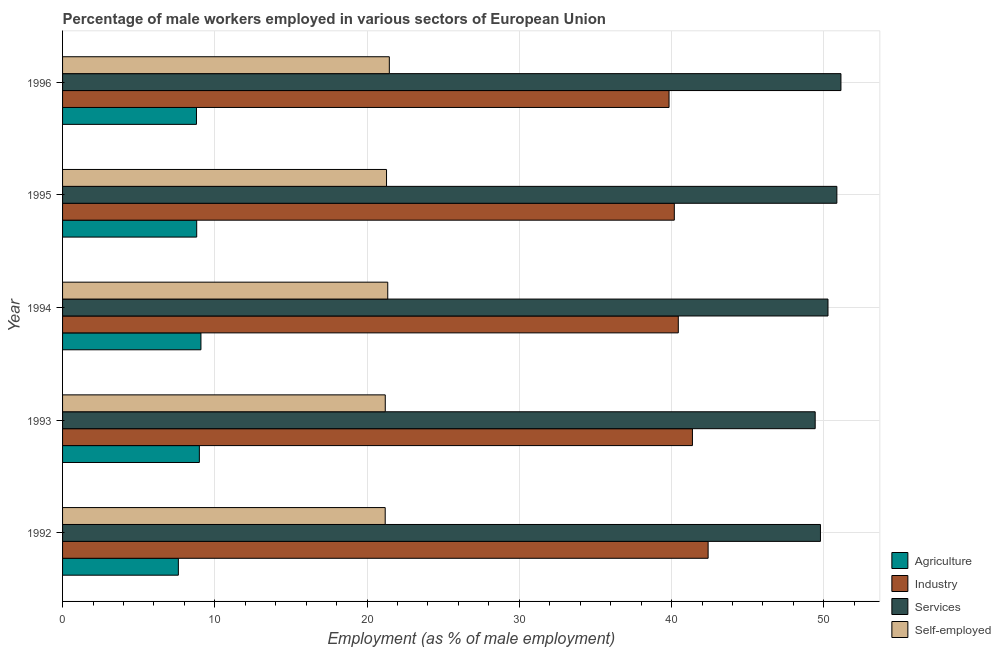How many different coloured bars are there?
Keep it short and to the point. 4. Are the number of bars on each tick of the Y-axis equal?
Your answer should be very brief. Yes. In how many cases, is the number of bars for a given year not equal to the number of legend labels?
Your answer should be compact. 0. What is the percentage of male workers in agriculture in 1996?
Keep it short and to the point. 8.79. Across all years, what is the maximum percentage of self employed male workers?
Your answer should be compact. 21.46. Across all years, what is the minimum percentage of male workers in industry?
Ensure brevity in your answer.  39.83. In which year was the percentage of self employed male workers maximum?
Ensure brevity in your answer.  1996. In which year was the percentage of male workers in agriculture minimum?
Provide a short and direct response. 1992. What is the total percentage of self employed male workers in the graph?
Ensure brevity in your answer.  106.48. What is the difference between the percentage of male workers in industry in 1995 and that in 1996?
Provide a short and direct response. 0.35. What is the difference between the percentage of self employed male workers in 1995 and the percentage of male workers in industry in 1993?
Ensure brevity in your answer.  -20.09. What is the average percentage of male workers in services per year?
Provide a succinct answer. 50.29. In the year 1992, what is the difference between the percentage of male workers in agriculture and percentage of male workers in industry?
Your answer should be very brief. -34.79. What is the ratio of the percentage of male workers in services in 1993 to that in 1995?
Make the answer very short. 0.97. Is the percentage of male workers in services in 1992 less than that in 1996?
Ensure brevity in your answer.  Yes. What is the difference between the highest and the second highest percentage of male workers in agriculture?
Ensure brevity in your answer.  0.1. What is the difference between the highest and the lowest percentage of self employed male workers?
Offer a terse response. 0.27. In how many years, is the percentage of male workers in industry greater than the average percentage of male workers in industry taken over all years?
Make the answer very short. 2. Is it the case that in every year, the sum of the percentage of self employed male workers and percentage of male workers in agriculture is greater than the sum of percentage of male workers in services and percentage of male workers in industry?
Offer a terse response. No. What does the 1st bar from the top in 1993 represents?
Your answer should be very brief. Self-employed. What does the 4th bar from the bottom in 1993 represents?
Offer a terse response. Self-employed. What is the difference between two consecutive major ticks on the X-axis?
Provide a short and direct response. 10. Does the graph contain grids?
Offer a very short reply. Yes. Where does the legend appear in the graph?
Ensure brevity in your answer.  Bottom right. How are the legend labels stacked?
Your answer should be compact. Vertical. What is the title of the graph?
Provide a succinct answer. Percentage of male workers employed in various sectors of European Union. What is the label or title of the X-axis?
Ensure brevity in your answer.  Employment (as % of male employment). What is the label or title of the Y-axis?
Make the answer very short. Year. What is the Employment (as % of male employment) in Agriculture in 1992?
Provide a succinct answer. 7.6. What is the Employment (as % of male employment) in Industry in 1992?
Ensure brevity in your answer.  42.4. What is the Employment (as % of male employment) in Services in 1992?
Keep it short and to the point. 49.78. What is the Employment (as % of male employment) in Self-employed in 1992?
Keep it short and to the point. 21.19. What is the Employment (as % of male employment) in Agriculture in 1993?
Your response must be concise. 8.98. What is the Employment (as % of male employment) in Industry in 1993?
Your answer should be very brief. 41.37. What is the Employment (as % of male employment) in Services in 1993?
Offer a very short reply. 49.43. What is the Employment (as % of male employment) of Self-employed in 1993?
Your answer should be compact. 21.19. What is the Employment (as % of male employment) of Agriculture in 1994?
Your response must be concise. 9.09. What is the Employment (as % of male employment) in Industry in 1994?
Keep it short and to the point. 40.44. What is the Employment (as % of male employment) of Services in 1994?
Your answer should be compact. 50.27. What is the Employment (as % of male employment) in Self-employed in 1994?
Provide a succinct answer. 21.36. What is the Employment (as % of male employment) in Agriculture in 1995?
Ensure brevity in your answer.  8.81. What is the Employment (as % of male employment) in Industry in 1995?
Provide a short and direct response. 40.18. What is the Employment (as % of male employment) of Services in 1995?
Provide a succinct answer. 50.85. What is the Employment (as % of male employment) of Self-employed in 1995?
Make the answer very short. 21.28. What is the Employment (as % of male employment) of Agriculture in 1996?
Your answer should be compact. 8.79. What is the Employment (as % of male employment) in Industry in 1996?
Your response must be concise. 39.83. What is the Employment (as % of male employment) of Services in 1996?
Make the answer very short. 51.12. What is the Employment (as % of male employment) of Self-employed in 1996?
Offer a very short reply. 21.46. Across all years, what is the maximum Employment (as % of male employment) of Agriculture?
Make the answer very short. 9.09. Across all years, what is the maximum Employment (as % of male employment) of Industry?
Offer a terse response. 42.4. Across all years, what is the maximum Employment (as % of male employment) in Services?
Keep it short and to the point. 51.12. Across all years, what is the maximum Employment (as % of male employment) in Self-employed?
Your response must be concise. 21.46. Across all years, what is the minimum Employment (as % of male employment) in Agriculture?
Ensure brevity in your answer.  7.6. Across all years, what is the minimum Employment (as % of male employment) in Industry?
Keep it short and to the point. 39.83. Across all years, what is the minimum Employment (as % of male employment) in Services?
Offer a very short reply. 49.43. Across all years, what is the minimum Employment (as % of male employment) in Self-employed?
Your response must be concise. 21.19. What is the total Employment (as % of male employment) of Agriculture in the graph?
Your response must be concise. 43.28. What is the total Employment (as % of male employment) in Industry in the graph?
Offer a terse response. 204.22. What is the total Employment (as % of male employment) of Services in the graph?
Your answer should be very brief. 251.46. What is the total Employment (as % of male employment) in Self-employed in the graph?
Offer a terse response. 106.48. What is the difference between the Employment (as % of male employment) of Agriculture in 1992 and that in 1993?
Offer a very short reply. -1.38. What is the difference between the Employment (as % of male employment) of Industry in 1992 and that in 1993?
Offer a terse response. 1.03. What is the difference between the Employment (as % of male employment) of Services in 1992 and that in 1993?
Provide a short and direct response. 0.35. What is the difference between the Employment (as % of male employment) of Self-employed in 1992 and that in 1993?
Offer a terse response. -0. What is the difference between the Employment (as % of male employment) in Agriculture in 1992 and that in 1994?
Give a very brief answer. -1.48. What is the difference between the Employment (as % of male employment) in Industry in 1992 and that in 1994?
Provide a short and direct response. 1.96. What is the difference between the Employment (as % of male employment) in Services in 1992 and that in 1994?
Give a very brief answer. -0.49. What is the difference between the Employment (as % of male employment) in Self-employed in 1992 and that in 1994?
Your response must be concise. -0.17. What is the difference between the Employment (as % of male employment) of Agriculture in 1992 and that in 1995?
Ensure brevity in your answer.  -1.2. What is the difference between the Employment (as % of male employment) of Industry in 1992 and that in 1995?
Your response must be concise. 2.22. What is the difference between the Employment (as % of male employment) of Services in 1992 and that in 1995?
Offer a very short reply. -1.08. What is the difference between the Employment (as % of male employment) of Self-employed in 1992 and that in 1995?
Your response must be concise. -0.09. What is the difference between the Employment (as % of male employment) of Agriculture in 1992 and that in 1996?
Ensure brevity in your answer.  -1.19. What is the difference between the Employment (as % of male employment) in Industry in 1992 and that in 1996?
Provide a short and direct response. 2.57. What is the difference between the Employment (as % of male employment) in Services in 1992 and that in 1996?
Your response must be concise. -1.35. What is the difference between the Employment (as % of male employment) of Self-employed in 1992 and that in 1996?
Give a very brief answer. -0.27. What is the difference between the Employment (as % of male employment) in Agriculture in 1993 and that in 1994?
Provide a succinct answer. -0.1. What is the difference between the Employment (as % of male employment) in Industry in 1993 and that in 1994?
Make the answer very short. 0.93. What is the difference between the Employment (as % of male employment) in Services in 1993 and that in 1994?
Provide a succinct answer. -0.84. What is the difference between the Employment (as % of male employment) of Self-employed in 1993 and that in 1994?
Give a very brief answer. -0.16. What is the difference between the Employment (as % of male employment) of Agriculture in 1993 and that in 1995?
Provide a short and direct response. 0.17. What is the difference between the Employment (as % of male employment) of Industry in 1993 and that in 1995?
Ensure brevity in your answer.  1.19. What is the difference between the Employment (as % of male employment) of Services in 1993 and that in 1995?
Provide a succinct answer. -1.42. What is the difference between the Employment (as % of male employment) in Self-employed in 1993 and that in 1995?
Give a very brief answer. -0.08. What is the difference between the Employment (as % of male employment) in Agriculture in 1993 and that in 1996?
Your answer should be compact. 0.19. What is the difference between the Employment (as % of male employment) in Industry in 1993 and that in 1996?
Make the answer very short. 1.54. What is the difference between the Employment (as % of male employment) of Services in 1993 and that in 1996?
Ensure brevity in your answer.  -1.69. What is the difference between the Employment (as % of male employment) of Self-employed in 1993 and that in 1996?
Give a very brief answer. -0.27. What is the difference between the Employment (as % of male employment) of Agriculture in 1994 and that in 1995?
Offer a very short reply. 0.28. What is the difference between the Employment (as % of male employment) in Industry in 1994 and that in 1995?
Provide a succinct answer. 0.26. What is the difference between the Employment (as % of male employment) in Services in 1994 and that in 1995?
Offer a very short reply. -0.58. What is the difference between the Employment (as % of male employment) of Self-employed in 1994 and that in 1995?
Provide a short and direct response. 0.08. What is the difference between the Employment (as % of male employment) in Agriculture in 1994 and that in 1996?
Your response must be concise. 0.29. What is the difference between the Employment (as % of male employment) in Industry in 1994 and that in 1996?
Your answer should be very brief. 0.61. What is the difference between the Employment (as % of male employment) in Services in 1994 and that in 1996?
Provide a short and direct response. -0.85. What is the difference between the Employment (as % of male employment) of Self-employed in 1994 and that in 1996?
Your answer should be compact. -0.1. What is the difference between the Employment (as % of male employment) of Agriculture in 1995 and that in 1996?
Keep it short and to the point. 0.01. What is the difference between the Employment (as % of male employment) of Industry in 1995 and that in 1996?
Ensure brevity in your answer.  0.35. What is the difference between the Employment (as % of male employment) of Services in 1995 and that in 1996?
Make the answer very short. -0.27. What is the difference between the Employment (as % of male employment) of Self-employed in 1995 and that in 1996?
Provide a succinct answer. -0.18. What is the difference between the Employment (as % of male employment) of Agriculture in 1992 and the Employment (as % of male employment) of Industry in 1993?
Keep it short and to the point. -33.76. What is the difference between the Employment (as % of male employment) in Agriculture in 1992 and the Employment (as % of male employment) in Services in 1993?
Ensure brevity in your answer.  -41.83. What is the difference between the Employment (as % of male employment) in Agriculture in 1992 and the Employment (as % of male employment) in Self-employed in 1993?
Provide a short and direct response. -13.59. What is the difference between the Employment (as % of male employment) of Industry in 1992 and the Employment (as % of male employment) of Services in 1993?
Make the answer very short. -7.03. What is the difference between the Employment (as % of male employment) of Industry in 1992 and the Employment (as % of male employment) of Self-employed in 1993?
Offer a terse response. 21.2. What is the difference between the Employment (as % of male employment) of Services in 1992 and the Employment (as % of male employment) of Self-employed in 1993?
Give a very brief answer. 28.58. What is the difference between the Employment (as % of male employment) in Agriculture in 1992 and the Employment (as % of male employment) in Industry in 1994?
Offer a terse response. -32.84. What is the difference between the Employment (as % of male employment) in Agriculture in 1992 and the Employment (as % of male employment) in Services in 1994?
Give a very brief answer. -42.67. What is the difference between the Employment (as % of male employment) in Agriculture in 1992 and the Employment (as % of male employment) in Self-employed in 1994?
Make the answer very short. -13.75. What is the difference between the Employment (as % of male employment) in Industry in 1992 and the Employment (as % of male employment) in Services in 1994?
Ensure brevity in your answer.  -7.87. What is the difference between the Employment (as % of male employment) in Industry in 1992 and the Employment (as % of male employment) in Self-employed in 1994?
Provide a succinct answer. 21.04. What is the difference between the Employment (as % of male employment) of Services in 1992 and the Employment (as % of male employment) of Self-employed in 1994?
Your answer should be very brief. 28.42. What is the difference between the Employment (as % of male employment) in Agriculture in 1992 and the Employment (as % of male employment) in Industry in 1995?
Offer a very short reply. -32.57. What is the difference between the Employment (as % of male employment) of Agriculture in 1992 and the Employment (as % of male employment) of Services in 1995?
Offer a very short reply. -43.25. What is the difference between the Employment (as % of male employment) in Agriculture in 1992 and the Employment (as % of male employment) in Self-employed in 1995?
Provide a succinct answer. -13.67. What is the difference between the Employment (as % of male employment) of Industry in 1992 and the Employment (as % of male employment) of Services in 1995?
Keep it short and to the point. -8.46. What is the difference between the Employment (as % of male employment) of Industry in 1992 and the Employment (as % of male employment) of Self-employed in 1995?
Offer a very short reply. 21.12. What is the difference between the Employment (as % of male employment) in Services in 1992 and the Employment (as % of male employment) in Self-employed in 1995?
Offer a terse response. 28.5. What is the difference between the Employment (as % of male employment) in Agriculture in 1992 and the Employment (as % of male employment) in Industry in 1996?
Offer a terse response. -32.23. What is the difference between the Employment (as % of male employment) of Agriculture in 1992 and the Employment (as % of male employment) of Services in 1996?
Make the answer very short. -43.52. What is the difference between the Employment (as % of male employment) in Agriculture in 1992 and the Employment (as % of male employment) in Self-employed in 1996?
Provide a short and direct response. -13.86. What is the difference between the Employment (as % of male employment) of Industry in 1992 and the Employment (as % of male employment) of Services in 1996?
Give a very brief answer. -8.72. What is the difference between the Employment (as % of male employment) of Industry in 1992 and the Employment (as % of male employment) of Self-employed in 1996?
Keep it short and to the point. 20.94. What is the difference between the Employment (as % of male employment) in Services in 1992 and the Employment (as % of male employment) in Self-employed in 1996?
Offer a very short reply. 28.32. What is the difference between the Employment (as % of male employment) of Agriculture in 1993 and the Employment (as % of male employment) of Industry in 1994?
Make the answer very short. -31.46. What is the difference between the Employment (as % of male employment) in Agriculture in 1993 and the Employment (as % of male employment) in Services in 1994?
Your answer should be compact. -41.29. What is the difference between the Employment (as % of male employment) of Agriculture in 1993 and the Employment (as % of male employment) of Self-employed in 1994?
Your answer should be very brief. -12.37. What is the difference between the Employment (as % of male employment) of Industry in 1993 and the Employment (as % of male employment) of Services in 1994?
Offer a terse response. -8.9. What is the difference between the Employment (as % of male employment) of Industry in 1993 and the Employment (as % of male employment) of Self-employed in 1994?
Make the answer very short. 20.01. What is the difference between the Employment (as % of male employment) in Services in 1993 and the Employment (as % of male employment) in Self-employed in 1994?
Your answer should be very brief. 28.07. What is the difference between the Employment (as % of male employment) in Agriculture in 1993 and the Employment (as % of male employment) in Industry in 1995?
Your answer should be compact. -31.2. What is the difference between the Employment (as % of male employment) of Agriculture in 1993 and the Employment (as % of male employment) of Services in 1995?
Provide a short and direct response. -41.87. What is the difference between the Employment (as % of male employment) in Agriculture in 1993 and the Employment (as % of male employment) in Self-employed in 1995?
Give a very brief answer. -12.29. What is the difference between the Employment (as % of male employment) in Industry in 1993 and the Employment (as % of male employment) in Services in 1995?
Keep it short and to the point. -9.49. What is the difference between the Employment (as % of male employment) in Industry in 1993 and the Employment (as % of male employment) in Self-employed in 1995?
Offer a very short reply. 20.09. What is the difference between the Employment (as % of male employment) of Services in 1993 and the Employment (as % of male employment) of Self-employed in 1995?
Give a very brief answer. 28.15. What is the difference between the Employment (as % of male employment) in Agriculture in 1993 and the Employment (as % of male employment) in Industry in 1996?
Offer a terse response. -30.85. What is the difference between the Employment (as % of male employment) in Agriculture in 1993 and the Employment (as % of male employment) in Services in 1996?
Your answer should be compact. -42.14. What is the difference between the Employment (as % of male employment) of Agriculture in 1993 and the Employment (as % of male employment) of Self-employed in 1996?
Offer a very short reply. -12.48. What is the difference between the Employment (as % of male employment) in Industry in 1993 and the Employment (as % of male employment) in Services in 1996?
Your response must be concise. -9.75. What is the difference between the Employment (as % of male employment) in Industry in 1993 and the Employment (as % of male employment) in Self-employed in 1996?
Your answer should be compact. 19.91. What is the difference between the Employment (as % of male employment) of Services in 1993 and the Employment (as % of male employment) of Self-employed in 1996?
Your answer should be compact. 27.97. What is the difference between the Employment (as % of male employment) in Agriculture in 1994 and the Employment (as % of male employment) in Industry in 1995?
Keep it short and to the point. -31.09. What is the difference between the Employment (as % of male employment) in Agriculture in 1994 and the Employment (as % of male employment) in Services in 1995?
Your answer should be compact. -41.77. What is the difference between the Employment (as % of male employment) in Agriculture in 1994 and the Employment (as % of male employment) in Self-employed in 1995?
Ensure brevity in your answer.  -12.19. What is the difference between the Employment (as % of male employment) of Industry in 1994 and the Employment (as % of male employment) of Services in 1995?
Ensure brevity in your answer.  -10.41. What is the difference between the Employment (as % of male employment) in Industry in 1994 and the Employment (as % of male employment) in Self-employed in 1995?
Provide a succinct answer. 19.16. What is the difference between the Employment (as % of male employment) of Services in 1994 and the Employment (as % of male employment) of Self-employed in 1995?
Provide a short and direct response. 28.99. What is the difference between the Employment (as % of male employment) in Agriculture in 1994 and the Employment (as % of male employment) in Industry in 1996?
Offer a terse response. -30.75. What is the difference between the Employment (as % of male employment) in Agriculture in 1994 and the Employment (as % of male employment) in Services in 1996?
Your response must be concise. -42.03. What is the difference between the Employment (as % of male employment) of Agriculture in 1994 and the Employment (as % of male employment) of Self-employed in 1996?
Provide a short and direct response. -12.37. What is the difference between the Employment (as % of male employment) in Industry in 1994 and the Employment (as % of male employment) in Services in 1996?
Provide a short and direct response. -10.68. What is the difference between the Employment (as % of male employment) of Industry in 1994 and the Employment (as % of male employment) of Self-employed in 1996?
Your response must be concise. 18.98. What is the difference between the Employment (as % of male employment) of Services in 1994 and the Employment (as % of male employment) of Self-employed in 1996?
Provide a short and direct response. 28.81. What is the difference between the Employment (as % of male employment) in Agriculture in 1995 and the Employment (as % of male employment) in Industry in 1996?
Your response must be concise. -31.02. What is the difference between the Employment (as % of male employment) of Agriculture in 1995 and the Employment (as % of male employment) of Services in 1996?
Provide a short and direct response. -42.31. What is the difference between the Employment (as % of male employment) of Agriculture in 1995 and the Employment (as % of male employment) of Self-employed in 1996?
Give a very brief answer. -12.65. What is the difference between the Employment (as % of male employment) in Industry in 1995 and the Employment (as % of male employment) in Services in 1996?
Your answer should be compact. -10.94. What is the difference between the Employment (as % of male employment) of Industry in 1995 and the Employment (as % of male employment) of Self-employed in 1996?
Make the answer very short. 18.72. What is the difference between the Employment (as % of male employment) in Services in 1995 and the Employment (as % of male employment) in Self-employed in 1996?
Ensure brevity in your answer.  29.39. What is the average Employment (as % of male employment) in Agriculture per year?
Give a very brief answer. 8.66. What is the average Employment (as % of male employment) in Industry per year?
Your response must be concise. 40.84. What is the average Employment (as % of male employment) in Services per year?
Your answer should be very brief. 50.29. What is the average Employment (as % of male employment) in Self-employed per year?
Give a very brief answer. 21.3. In the year 1992, what is the difference between the Employment (as % of male employment) in Agriculture and Employment (as % of male employment) in Industry?
Offer a very short reply. -34.79. In the year 1992, what is the difference between the Employment (as % of male employment) of Agriculture and Employment (as % of male employment) of Services?
Give a very brief answer. -42.17. In the year 1992, what is the difference between the Employment (as % of male employment) of Agriculture and Employment (as % of male employment) of Self-employed?
Offer a terse response. -13.59. In the year 1992, what is the difference between the Employment (as % of male employment) of Industry and Employment (as % of male employment) of Services?
Provide a short and direct response. -7.38. In the year 1992, what is the difference between the Employment (as % of male employment) of Industry and Employment (as % of male employment) of Self-employed?
Provide a short and direct response. 21.21. In the year 1992, what is the difference between the Employment (as % of male employment) of Services and Employment (as % of male employment) of Self-employed?
Give a very brief answer. 28.59. In the year 1993, what is the difference between the Employment (as % of male employment) in Agriculture and Employment (as % of male employment) in Industry?
Provide a short and direct response. -32.39. In the year 1993, what is the difference between the Employment (as % of male employment) in Agriculture and Employment (as % of male employment) in Services?
Provide a short and direct response. -40.45. In the year 1993, what is the difference between the Employment (as % of male employment) of Agriculture and Employment (as % of male employment) of Self-employed?
Your answer should be very brief. -12.21. In the year 1993, what is the difference between the Employment (as % of male employment) in Industry and Employment (as % of male employment) in Services?
Offer a very short reply. -8.06. In the year 1993, what is the difference between the Employment (as % of male employment) of Industry and Employment (as % of male employment) of Self-employed?
Ensure brevity in your answer.  20.17. In the year 1993, what is the difference between the Employment (as % of male employment) of Services and Employment (as % of male employment) of Self-employed?
Provide a succinct answer. 28.24. In the year 1994, what is the difference between the Employment (as % of male employment) of Agriculture and Employment (as % of male employment) of Industry?
Keep it short and to the point. -31.35. In the year 1994, what is the difference between the Employment (as % of male employment) of Agriculture and Employment (as % of male employment) of Services?
Provide a succinct answer. -41.18. In the year 1994, what is the difference between the Employment (as % of male employment) in Agriculture and Employment (as % of male employment) in Self-employed?
Keep it short and to the point. -12.27. In the year 1994, what is the difference between the Employment (as % of male employment) in Industry and Employment (as % of male employment) in Services?
Your response must be concise. -9.83. In the year 1994, what is the difference between the Employment (as % of male employment) in Industry and Employment (as % of male employment) in Self-employed?
Your response must be concise. 19.08. In the year 1994, what is the difference between the Employment (as % of male employment) of Services and Employment (as % of male employment) of Self-employed?
Your response must be concise. 28.91. In the year 1995, what is the difference between the Employment (as % of male employment) of Agriculture and Employment (as % of male employment) of Industry?
Your answer should be very brief. -31.37. In the year 1995, what is the difference between the Employment (as % of male employment) of Agriculture and Employment (as % of male employment) of Services?
Make the answer very short. -42.04. In the year 1995, what is the difference between the Employment (as % of male employment) in Agriculture and Employment (as % of male employment) in Self-employed?
Offer a terse response. -12.47. In the year 1995, what is the difference between the Employment (as % of male employment) in Industry and Employment (as % of male employment) in Services?
Give a very brief answer. -10.68. In the year 1995, what is the difference between the Employment (as % of male employment) in Industry and Employment (as % of male employment) in Self-employed?
Your answer should be compact. 18.9. In the year 1995, what is the difference between the Employment (as % of male employment) in Services and Employment (as % of male employment) in Self-employed?
Provide a succinct answer. 29.58. In the year 1996, what is the difference between the Employment (as % of male employment) of Agriculture and Employment (as % of male employment) of Industry?
Offer a very short reply. -31.04. In the year 1996, what is the difference between the Employment (as % of male employment) of Agriculture and Employment (as % of male employment) of Services?
Offer a very short reply. -42.33. In the year 1996, what is the difference between the Employment (as % of male employment) in Agriculture and Employment (as % of male employment) in Self-employed?
Offer a terse response. -12.67. In the year 1996, what is the difference between the Employment (as % of male employment) in Industry and Employment (as % of male employment) in Services?
Offer a very short reply. -11.29. In the year 1996, what is the difference between the Employment (as % of male employment) of Industry and Employment (as % of male employment) of Self-employed?
Provide a succinct answer. 18.37. In the year 1996, what is the difference between the Employment (as % of male employment) of Services and Employment (as % of male employment) of Self-employed?
Ensure brevity in your answer.  29.66. What is the ratio of the Employment (as % of male employment) of Agriculture in 1992 to that in 1993?
Provide a short and direct response. 0.85. What is the ratio of the Employment (as % of male employment) of Industry in 1992 to that in 1993?
Ensure brevity in your answer.  1.02. What is the ratio of the Employment (as % of male employment) in Agriculture in 1992 to that in 1994?
Offer a terse response. 0.84. What is the ratio of the Employment (as % of male employment) in Industry in 1992 to that in 1994?
Make the answer very short. 1.05. What is the ratio of the Employment (as % of male employment) of Services in 1992 to that in 1994?
Your response must be concise. 0.99. What is the ratio of the Employment (as % of male employment) of Agriculture in 1992 to that in 1995?
Give a very brief answer. 0.86. What is the ratio of the Employment (as % of male employment) of Industry in 1992 to that in 1995?
Keep it short and to the point. 1.06. What is the ratio of the Employment (as % of male employment) in Services in 1992 to that in 1995?
Provide a short and direct response. 0.98. What is the ratio of the Employment (as % of male employment) in Agriculture in 1992 to that in 1996?
Offer a terse response. 0.86. What is the ratio of the Employment (as % of male employment) of Industry in 1992 to that in 1996?
Your response must be concise. 1.06. What is the ratio of the Employment (as % of male employment) in Services in 1992 to that in 1996?
Your answer should be compact. 0.97. What is the ratio of the Employment (as % of male employment) of Self-employed in 1992 to that in 1996?
Your response must be concise. 0.99. What is the ratio of the Employment (as % of male employment) of Industry in 1993 to that in 1994?
Your answer should be compact. 1.02. What is the ratio of the Employment (as % of male employment) of Services in 1993 to that in 1994?
Make the answer very short. 0.98. What is the ratio of the Employment (as % of male employment) in Self-employed in 1993 to that in 1994?
Provide a short and direct response. 0.99. What is the ratio of the Employment (as % of male employment) in Agriculture in 1993 to that in 1995?
Offer a very short reply. 1.02. What is the ratio of the Employment (as % of male employment) in Industry in 1993 to that in 1995?
Keep it short and to the point. 1.03. What is the ratio of the Employment (as % of male employment) in Self-employed in 1993 to that in 1995?
Give a very brief answer. 1. What is the ratio of the Employment (as % of male employment) in Agriculture in 1993 to that in 1996?
Provide a succinct answer. 1.02. What is the ratio of the Employment (as % of male employment) of Industry in 1993 to that in 1996?
Give a very brief answer. 1.04. What is the ratio of the Employment (as % of male employment) in Services in 1993 to that in 1996?
Give a very brief answer. 0.97. What is the ratio of the Employment (as % of male employment) of Self-employed in 1993 to that in 1996?
Your answer should be very brief. 0.99. What is the ratio of the Employment (as % of male employment) in Agriculture in 1994 to that in 1995?
Provide a short and direct response. 1.03. What is the ratio of the Employment (as % of male employment) of Industry in 1994 to that in 1995?
Keep it short and to the point. 1.01. What is the ratio of the Employment (as % of male employment) in Industry in 1994 to that in 1996?
Your answer should be compact. 1.02. What is the ratio of the Employment (as % of male employment) of Services in 1994 to that in 1996?
Your answer should be very brief. 0.98. What is the ratio of the Employment (as % of male employment) of Industry in 1995 to that in 1996?
Offer a very short reply. 1.01. What is the ratio of the Employment (as % of male employment) in Services in 1995 to that in 1996?
Give a very brief answer. 0.99. What is the difference between the highest and the second highest Employment (as % of male employment) in Agriculture?
Offer a very short reply. 0.1. What is the difference between the highest and the second highest Employment (as % of male employment) in Industry?
Your response must be concise. 1.03. What is the difference between the highest and the second highest Employment (as % of male employment) in Services?
Offer a very short reply. 0.27. What is the difference between the highest and the second highest Employment (as % of male employment) in Self-employed?
Your response must be concise. 0.1. What is the difference between the highest and the lowest Employment (as % of male employment) of Agriculture?
Offer a terse response. 1.48. What is the difference between the highest and the lowest Employment (as % of male employment) of Industry?
Provide a succinct answer. 2.57. What is the difference between the highest and the lowest Employment (as % of male employment) of Services?
Your answer should be very brief. 1.69. What is the difference between the highest and the lowest Employment (as % of male employment) of Self-employed?
Ensure brevity in your answer.  0.27. 